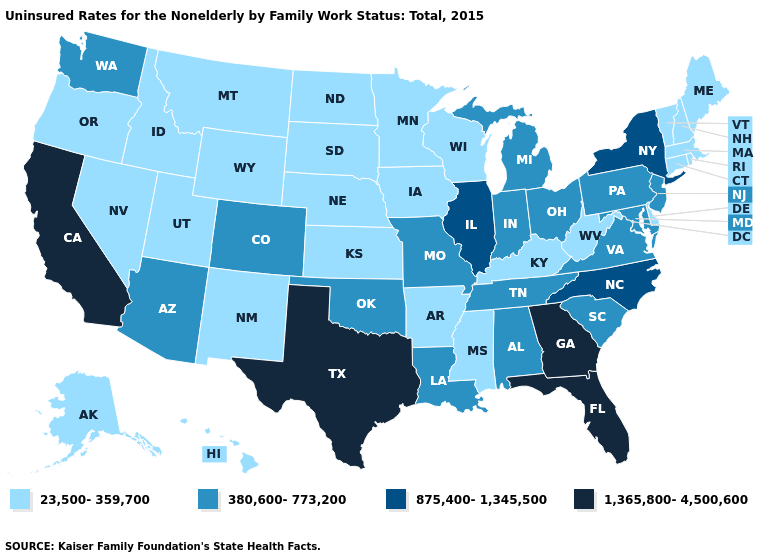What is the value of Florida?
Answer briefly. 1,365,800-4,500,600. Does Louisiana have a lower value than Mississippi?
Quick response, please. No. What is the highest value in the USA?
Keep it brief. 1,365,800-4,500,600. Name the states that have a value in the range 380,600-773,200?
Concise answer only. Alabama, Arizona, Colorado, Indiana, Louisiana, Maryland, Michigan, Missouri, New Jersey, Ohio, Oklahoma, Pennsylvania, South Carolina, Tennessee, Virginia, Washington. What is the lowest value in states that border Utah?
Write a very short answer. 23,500-359,700. What is the lowest value in the MidWest?
Be succinct. 23,500-359,700. Among the states that border New Mexico , which have the lowest value?
Quick response, please. Utah. Does Ohio have a lower value than Illinois?
Give a very brief answer. Yes. Does Michigan have the same value as South Carolina?
Answer briefly. Yes. What is the highest value in the USA?
Concise answer only. 1,365,800-4,500,600. What is the value of Oregon?
Short answer required. 23,500-359,700. Does Idaho have the same value as South Dakota?
Answer briefly. Yes. Among the states that border Arizona , which have the highest value?
Write a very short answer. California. Which states hav the highest value in the West?
Give a very brief answer. California. 